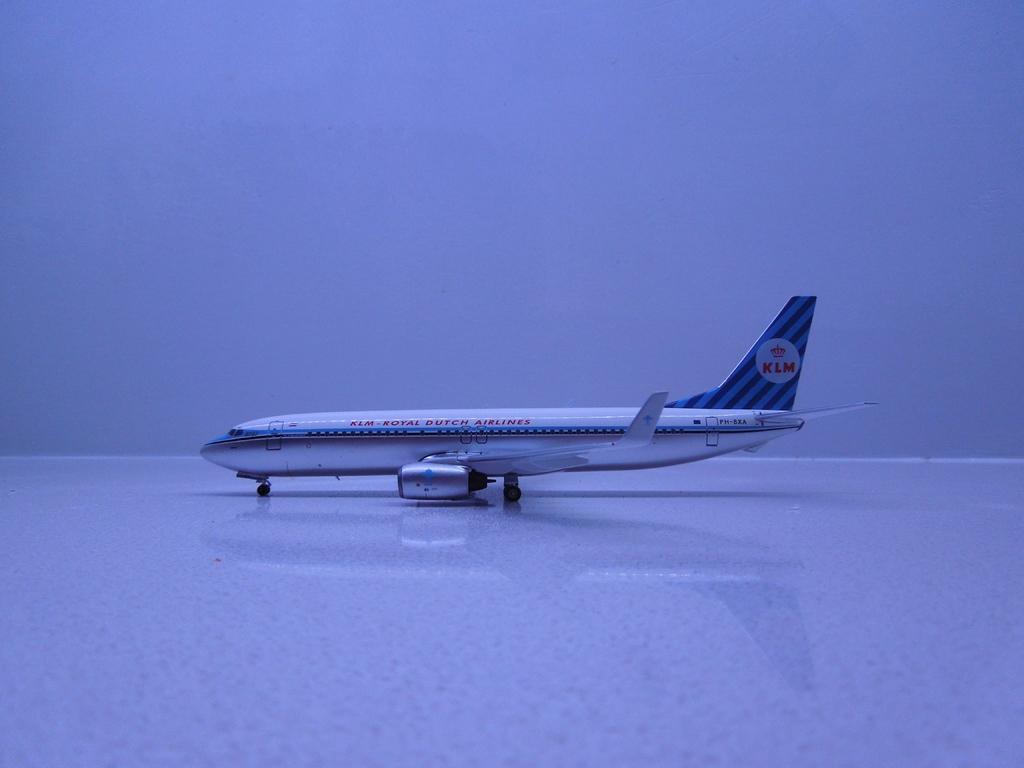How would you summarize this image in a sentence or two? In this image there is an airplane with some text written on it. 